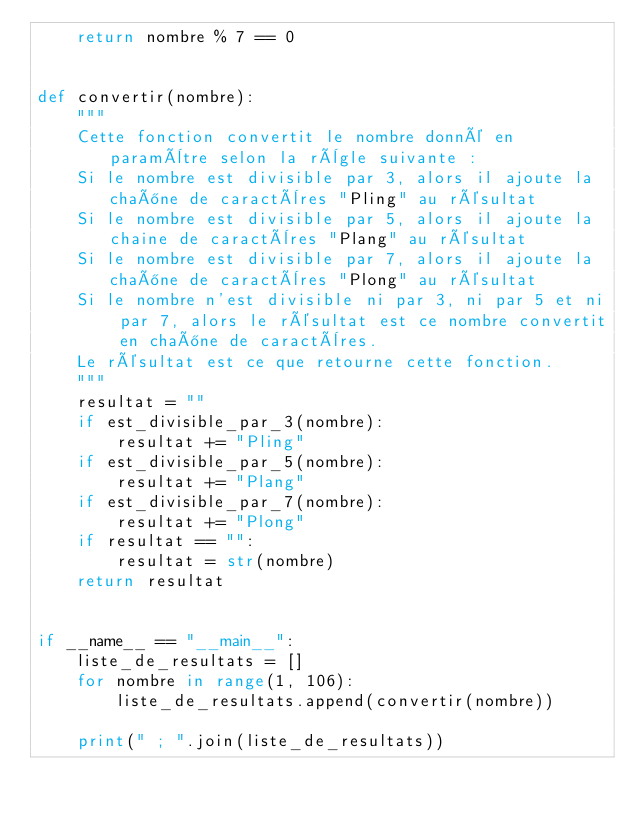<code> <loc_0><loc_0><loc_500><loc_500><_Python_>    return nombre % 7 == 0


def convertir(nombre):
    """
    Cette fonction convertit le nombre donné en paramètre selon la règle suivante :
    Si le nombre est divisible par 3, alors il ajoute la chaîne de caractères "Pling" au résultat
    Si le nombre est divisible par 5, alors il ajoute la chaine de caractères "Plang" au résultat
    Si le nombre est divisible par 7, alors il ajoute la chaîne de caractères "Plong" au résultat
    Si le nombre n'est divisible ni par 3, ni par 5 et ni par 7, alors le résultat est ce nombre convertit en chaîne de caractères.
    Le résultat est ce que retourne cette fonction.
    """
    resultat = ""
    if est_divisible_par_3(nombre):
        resultat += "Pling"
    if est_divisible_par_5(nombre):
        resultat += "Plang"
    if est_divisible_par_7(nombre):
        resultat += "Plong"
    if resultat == "":
        resultat = str(nombre)
    return resultat


if __name__ == "__main__":
    liste_de_resultats = []
    for nombre in range(1, 106):
        liste_de_resultats.append(convertir(nombre))

    print(" ; ".join(liste_de_resultats))
</code> 